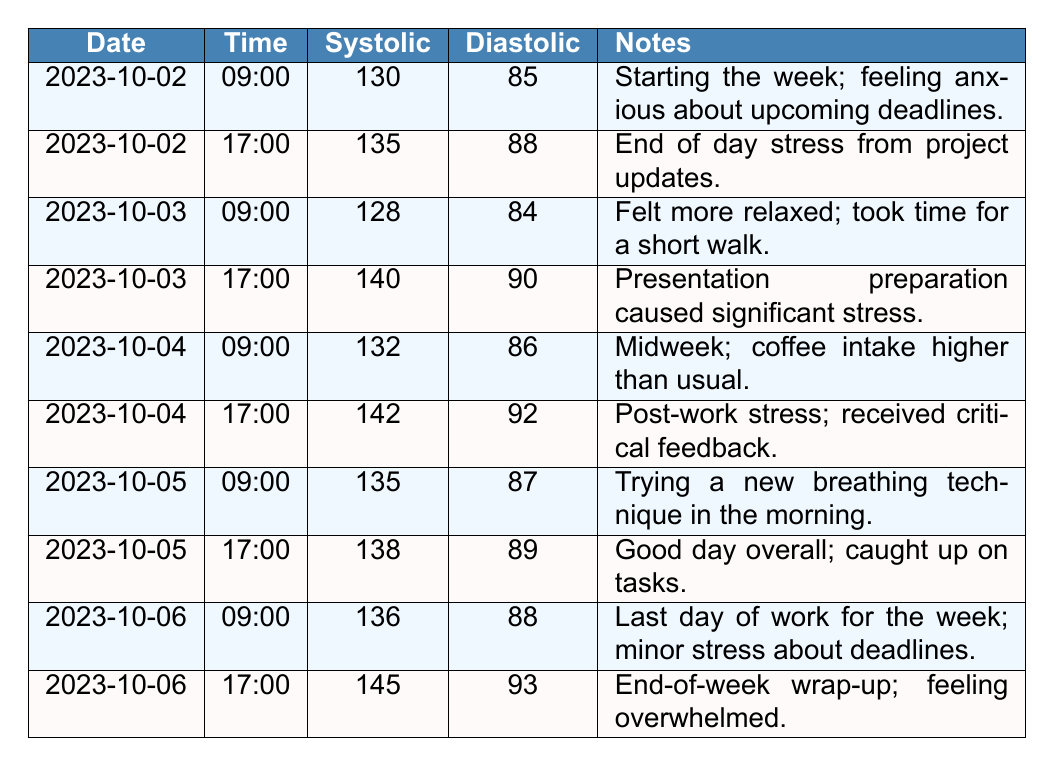What was the highest systolic reading recorded during the week? The highest systolic reading recorded is 145, which occurred on October 6 at 17:00.
Answer: 145 What was the lowest diastolic reading recorded during the week? The lowest diastolic reading recorded is 84, which occurred on October 3 at 09:00.
Answer: 84 Is there an indication that stress influenced blood pressure throughout the week? Yes, many notes correlate increased blood pressure with stressful events, such as project updates and critical feedback.
Answer: Yes What was the average systolic reading for the mornings (09:00) throughout the week? The systolic readings in the morning are 130, 128, 132, 135, and 136. Sum: 130 + 128 + 132 + 135 + 136 = 661. The average is 661 / 5 = 132.2.
Answer: 132.2 Did the systolic value increase or decrease from the morning to the evening on October 4? On October 4, the morning reading was 132, and the evening reading was 142. The value increased by 10.
Answer: Increased What was the difference in systolic readings between the highest and lowest values recorded? The highest systolic reading is 145, and the lowest is 128. The difference is 145 - 128 = 17.
Answer: 17 Were there any days where the diastolic readings exceeded 90? Yes, on October 4 (92) and October 6 (93), the diastolic readings exceeded 90.
Answer: Yes What trend in blood pressure can be observed from the beginning to the end of the week? The trend shows an overall increase in both systolic and diastolic readings, indicating a rise in stress levels by the end of the week.
Answer: Increase in blood pressure What was the note associated with the highest blood pressure reading? The highest reading of 145 was noted as related to the end-of-week wrap-up and feeling overwhelmed.
Answer: End-of-week wrap-up; feeling overwhelmed 